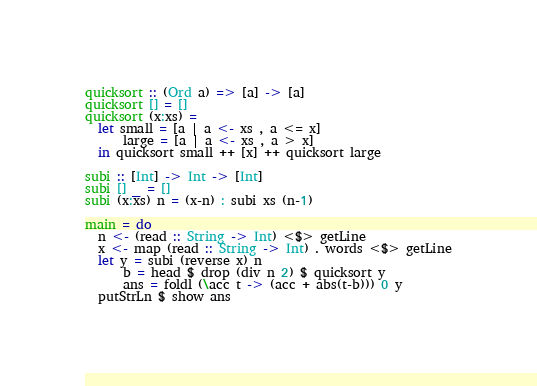Convert code to text. <code><loc_0><loc_0><loc_500><loc_500><_Haskell_>quicksort :: (Ord a) => [a] -> [a]
quicksort [] = []
quicksort (x:xs) =
  let small = [a | a <- xs , a <= x]
      large = [a | a <- xs , a > x]
  in quicksort small ++ [x] ++ quicksort large

subi :: [Int] -> Int -> [Int]
subi [] _ = []
subi (x:xs) n = (x-n) : subi xs (n-1)

main = do
  n <- (read :: String -> Int) <$> getLine
  x <- map (read :: String -> Int) . words <$> getLine
  let y = subi (reverse x) n
      b = head $ drop (div n 2) $ quicksort y
      ans = foldl (\acc t -> (acc + abs(t-b))) 0 y
  putStrLn $ show ans
</code> 